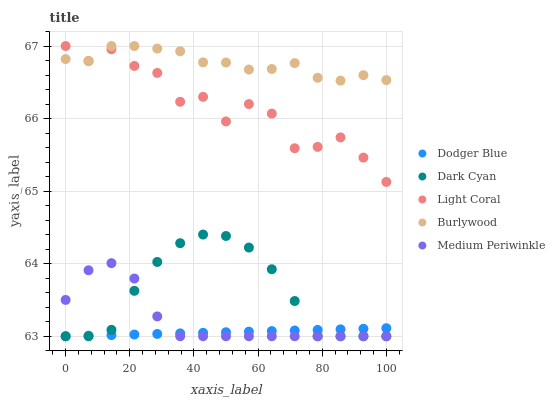Does Dodger Blue have the minimum area under the curve?
Answer yes or no. Yes. Does Burlywood have the maximum area under the curve?
Answer yes or no. Yes. Does Light Coral have the minimum area under the curve?
Answer yes or no. No. Does Light Coral have the maximum area under the curve?
Answer yes or no. No. Is Dodger Blue the smoothest?
Answer yes or no. Yes. Is Light Coral the roughest?
Answer yes or no. Yes. Is Light Coral the smoothest?
Answer yes or no. No. Is Dodger Blue the roughest?
Answer yes or no. No. Does Dark Cyan have the lowest value?
Answer yes or no. Yes. Does Light Coral have the lowest value?
Answer yes or no. No. Does Burlywood have the highest value?
Answer yes or no. Yes. Does Dodger Blue have the highest value?
Answer yes or no. No. Is Dark Cyan less than Light Coral?
Answer yes or no. Yes. Is Light Coral greater than Medium Periwinkle?
Answer yes or no. Yes. Does Burlywood intersect Light Coral?
Answer yes or no. Yes. Is Burlywood less than Light Coral?
Answer yes or no. No. Is Burlywood greater than Light Coral?
Answer yes or no. No. Does Dark Cyan intersect Light Coral?
Answer yes or no. No. 